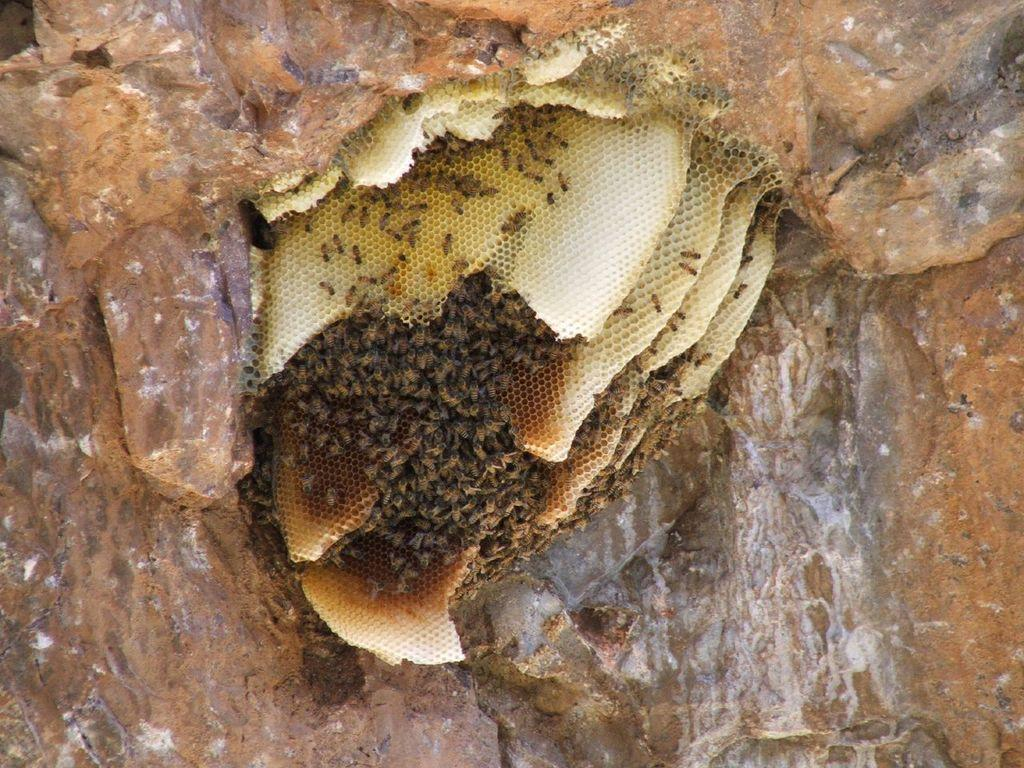What type of insects can be seen in the image? There are bees in the image. What structure are the bees associated with? There is a hive in the image. What is the hive resting on? The hive is on a stone. Where is the stone located in the image? The stone is in the foreground of the image. What type of tub is visible in the image? There is no tub present in the image. Is the hive connected to any electrical devices in the image? There is no indication of any electrical devices or connections in the image. 